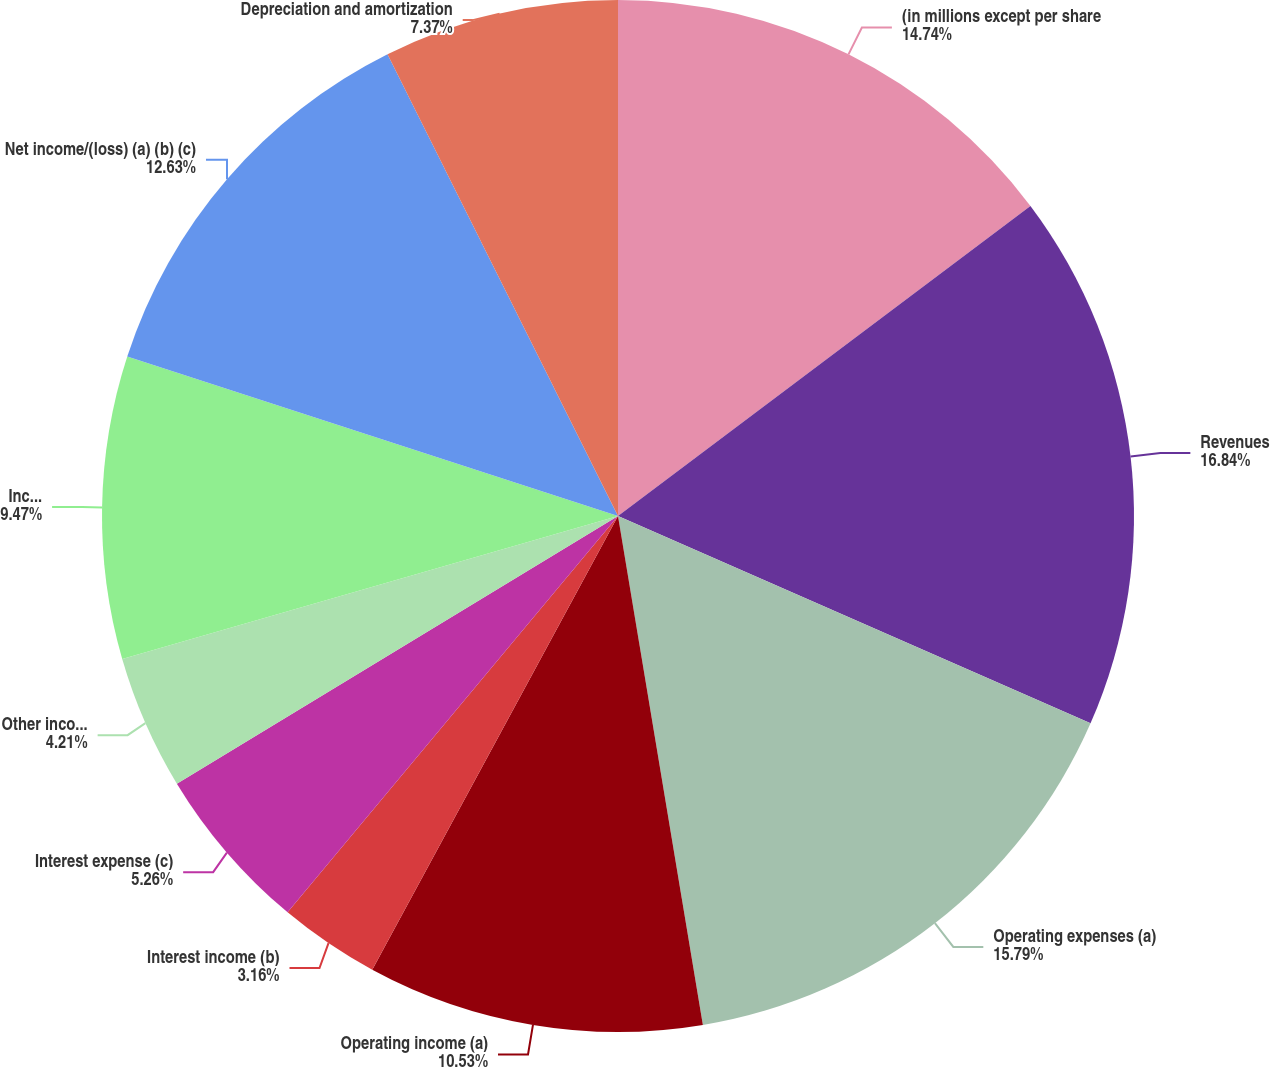Convert chart. <chart><loc_0><loc_0><loc_500><loc_500><pie_chart><fcel>(in millions except per share<fcel>Revenues<fcel>Operating expenses (a)<fcel>Operating income (a)<fcel>Interest income (b)<fcel>Interest expense (c)<fcel>Other income/(expense) net<fcel>Income before income taxes (a)<fcel>Net income/(loss) (a) (b) (c)<fcel>Depreciation and amortization<nl><fcel>14.74%<fcel>16.84%<fcel>15.79%<fcel>10.53%<fcel>3.16%<fcel>5.26%<fcel>4.21%<fcel>9.47%<fcel>12.63%<fcel>7.37%<nl></chart> 